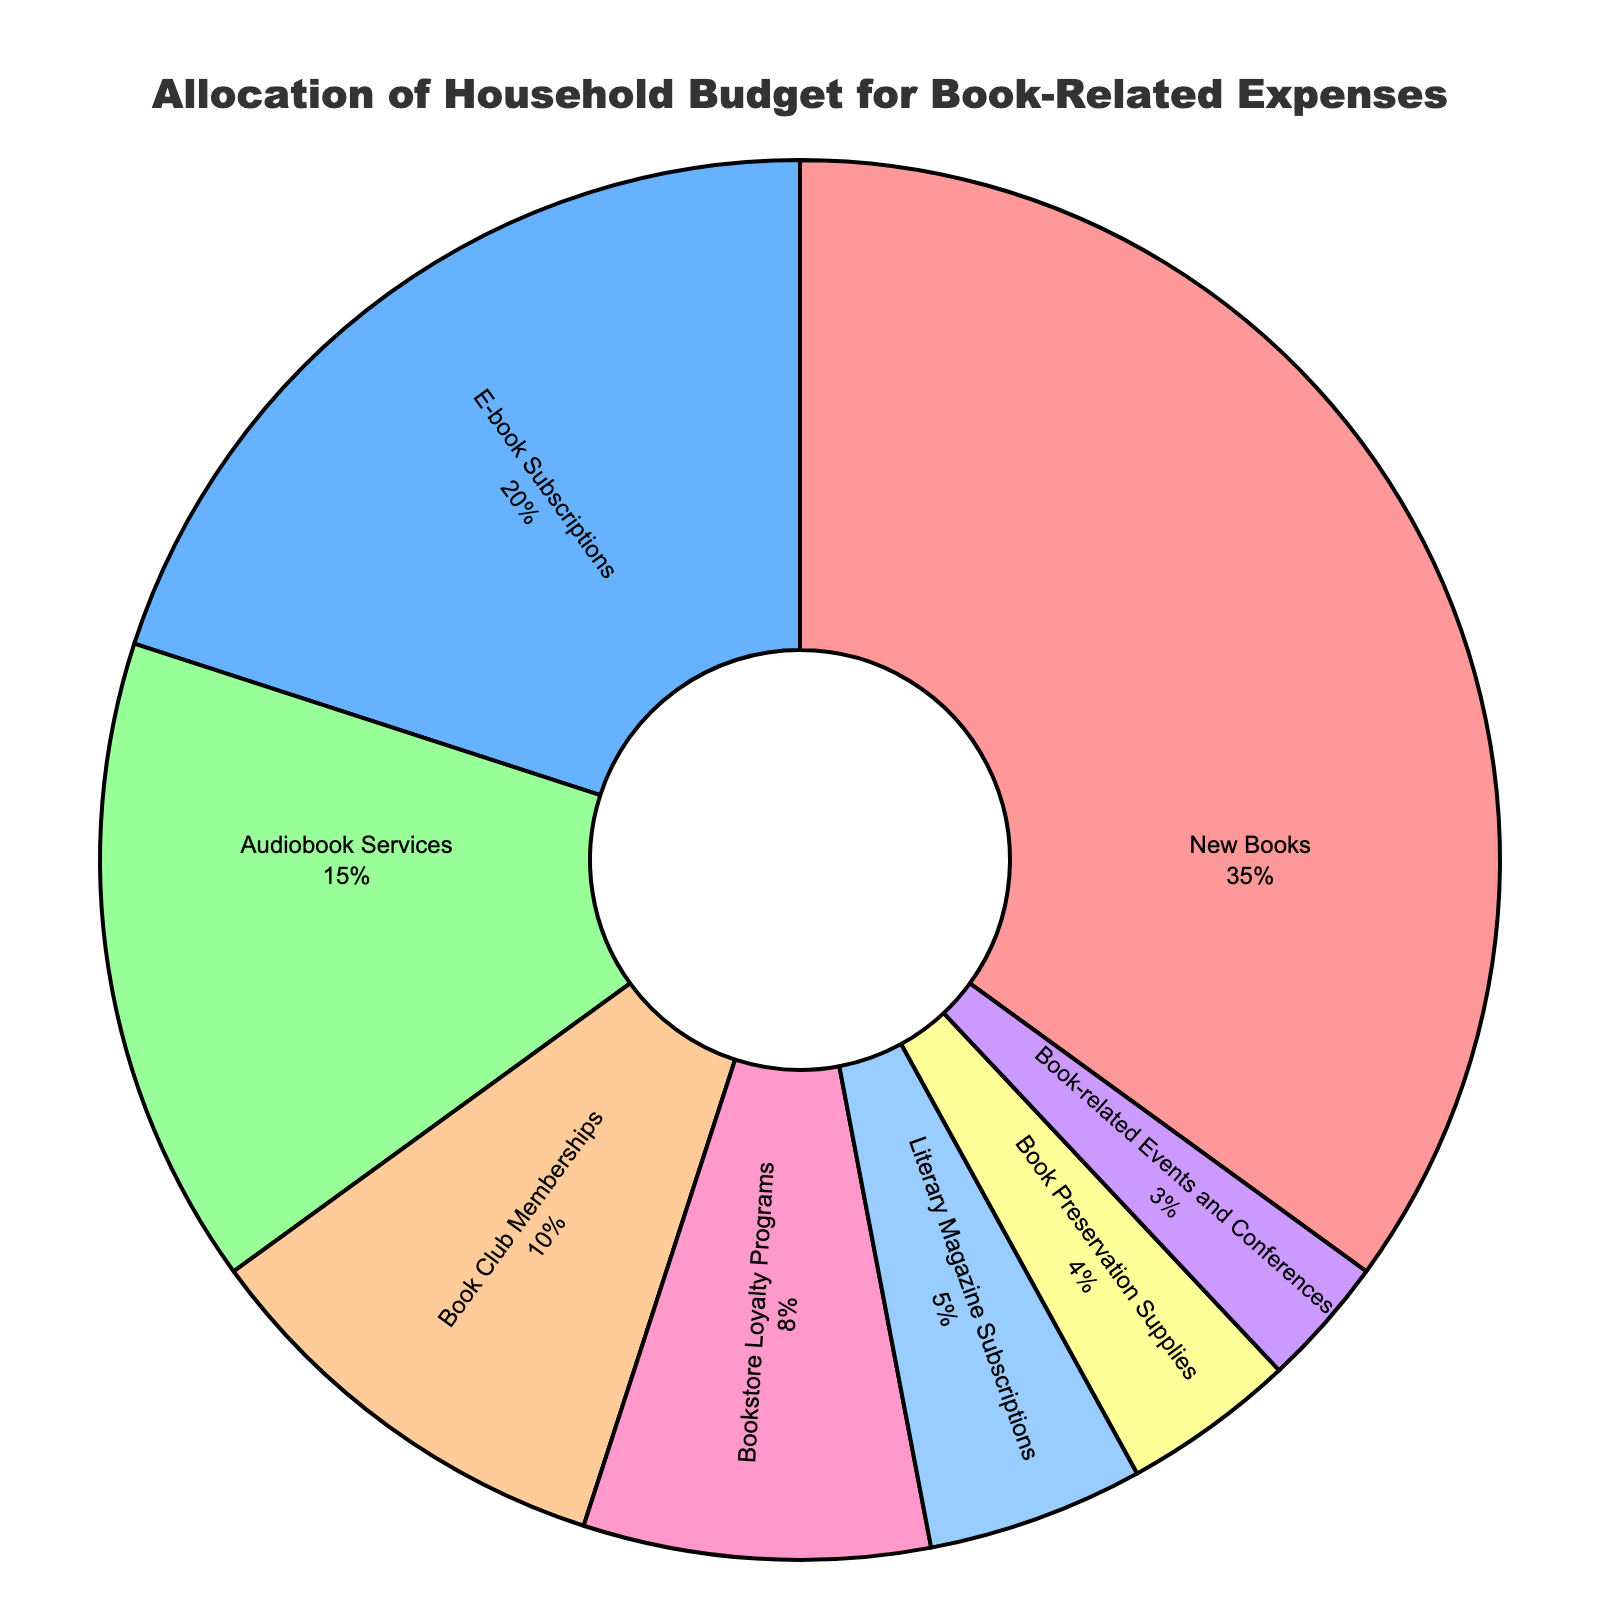what is the largest category of our book-related expenses? The largest segment in the pie chart is labeled "New Books" with a percentage of 35%.
Answer: New Books Which categories collectively make up more than half of our book-related expenses? Summing up the percentages of the largest categories: New Books (35%) + E-book Subscriptions (20%) = 55%.
Answer: New Books and E-book Subscriptions What is the difference in the percentage allocation between Audiobook Services and Book Club Memberships? Audiobook Services have 15% while Book Club Memberships have 10%. The difference is 15% - 10%.
Answer: 5% Which expense category has the smallest percentage? The smallest segment in the pie chart is labeled "Book-related Events and Conferences" with 3%.
Answer: Book-related Events and Conferences How do the percentages of Bookstore Loyalty Programs and Literary Magazine Subscriptions compare? Bookstore Loyalty Programs have 8% while Literary Magazine Subscriptions have 5%. 8% > 5%.
Answer: Bookstore Loyalty Programs have a higher percentage Which category uses a green color in the pie chart? The pie chart segment for "Audiobook Services" is colored green.
Answer: Audiobook Services What is the combined percentage of Bookstore Loyalty Programs and Book Preservation Supplies? Adding the two percentages: Bookstore Loyalty Programs (8%) + Book Preservation Supplies (4%) = 12%.
Answer: 12% Which category has a higher percentage: Literary Magazine Subscriptions or Book Preservation Supplies? Literary Magazine Subscriptions have 5% and Book Preservation Supplies have 4%. 5% > 4%.
Answer: Literary Magazine Subscriptions If we were to evenly split the budget for New Books among E-book Subscriptions and Audiobook Services, what percentage would each get? New Books have 35%, split among E-book Subscriptions and Audiobook Services: 35% / 2 = 17.5%.
Answer: 17.5% What are the percentages of the categories that have allocations less than 5%? The segments for Literary Magazine Subscriptions have 5%, Book Preservation Supplies 4%, and Book-related Events and Conferences 3%. Only Book Preservation Supplies and Book-related Events and Conferences fall under 5%.
Answer: 4% and 3% 